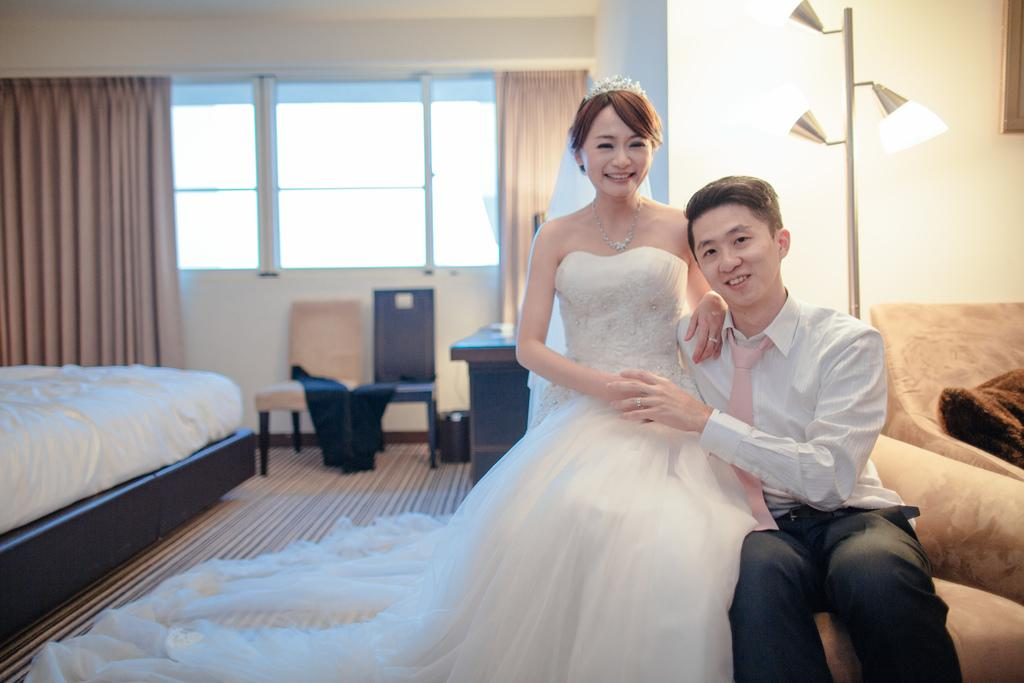How many people are in the image? There is a woman and a man in the image. What are the woman and man doing in the image? The woman and man are sitting next to each other. What can be seen in the background of the image? There is a sofa, a light lamp, a window, a chair, and a bed in the background of the image. What type of stick is being used to cause a reaction in the image? There is no stick or any reaction being caused in the image; it features a woman and a man sitting next to each other. What type of pan is visible on the bed in the image? There is no pan present in the image; it features a woman and a man sitting next to each other, along with various objects and furniture in the background. 